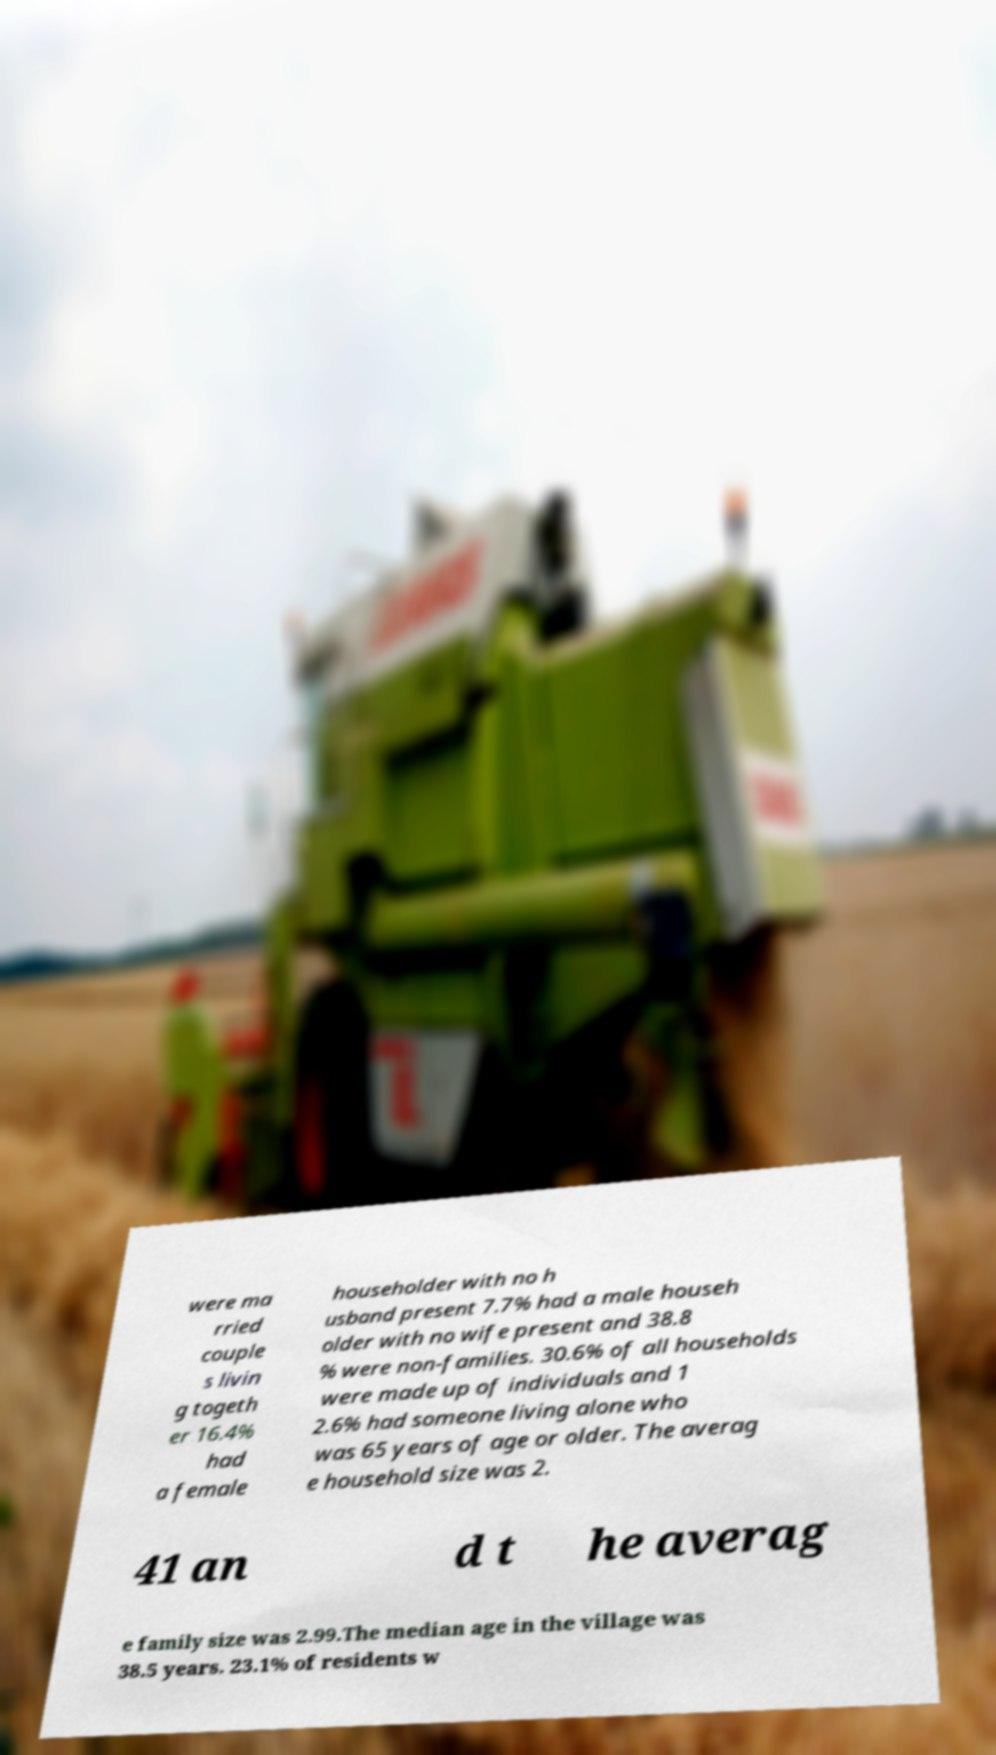What messages or text are displayed in this image? I need them in a readable, typed format. were ma rried couple s livin g togeth er 16.4% had a female householder with no h usband present 7.7% had a male househ older with no wife present and 38.8 % were non-families. 30.6% of all households were made up of individuals and 1 2.6% had someone living alone who was 65 years of age or older. The averag e household size was 2. 41 an d t he averag e family size was 2.99.The median age in the village was 38.5 years. 23.1% of residents w 